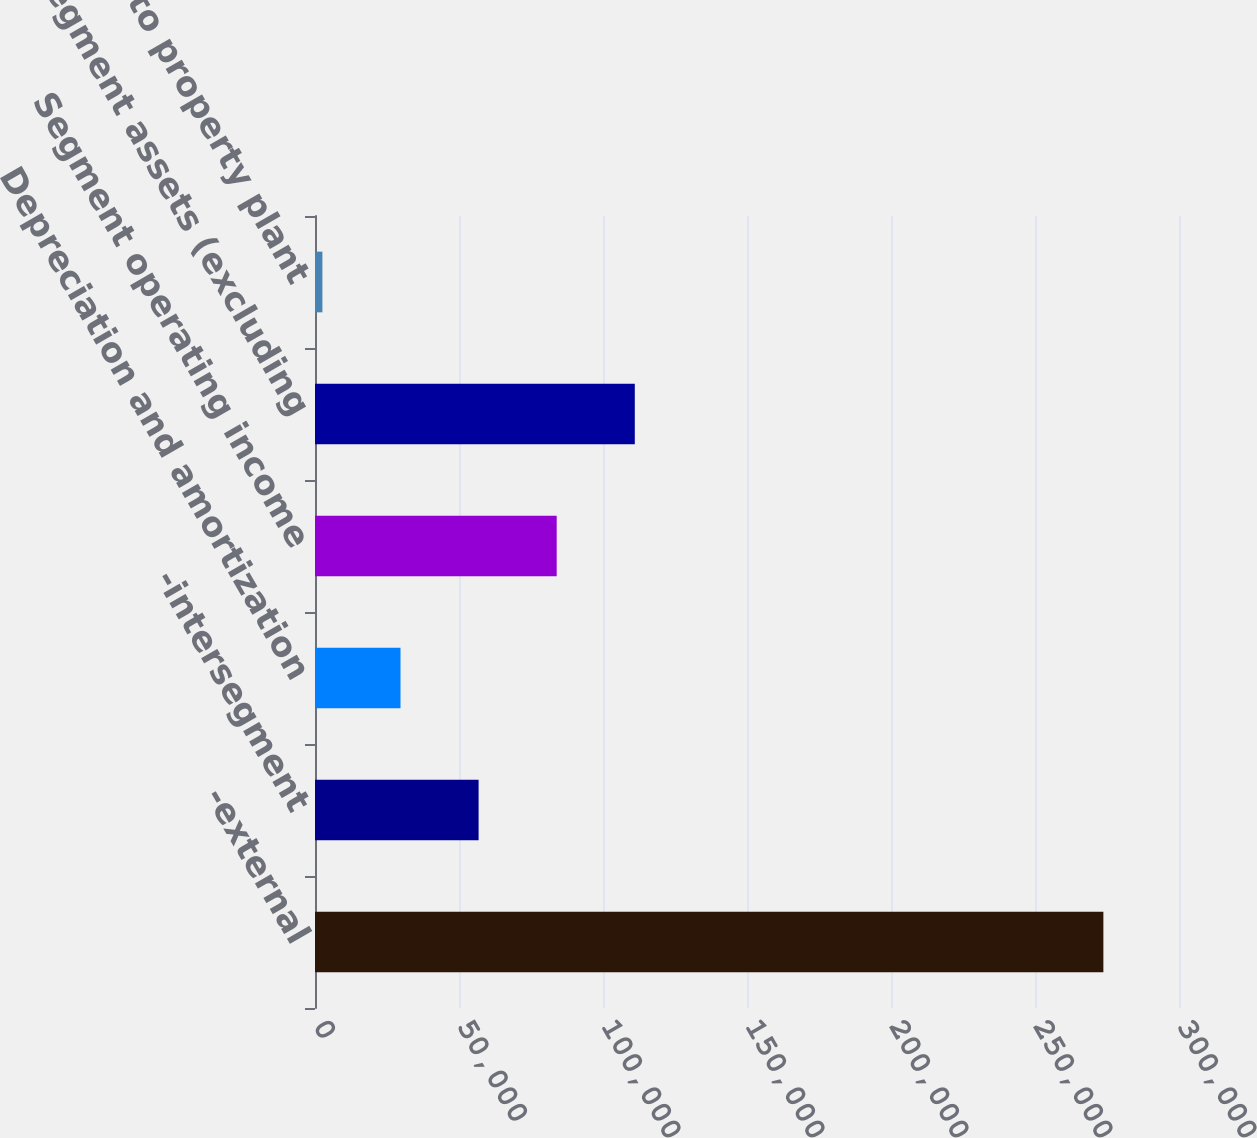<chart> <loc_0><loc_0><loc_500><loc_500><bar_chart><fcel>-external<fcel>-intersegment<fcel>Depreciation and amortization<fcel>Segment operating income<fcel>Segment assets (excluding<fcel>Additions to property plant<nl><fcel>273744<fcel>56804.8<fcel>29687.4<fcel>83922.2<fcel>111040<fcel>2570<nl></chart> 